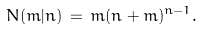<formula> <loc_0><loc_0><loc_500><loc_500>N ( m | n ) \, = \, m ( n + m ) ^ { n - 1 } .</formula> 